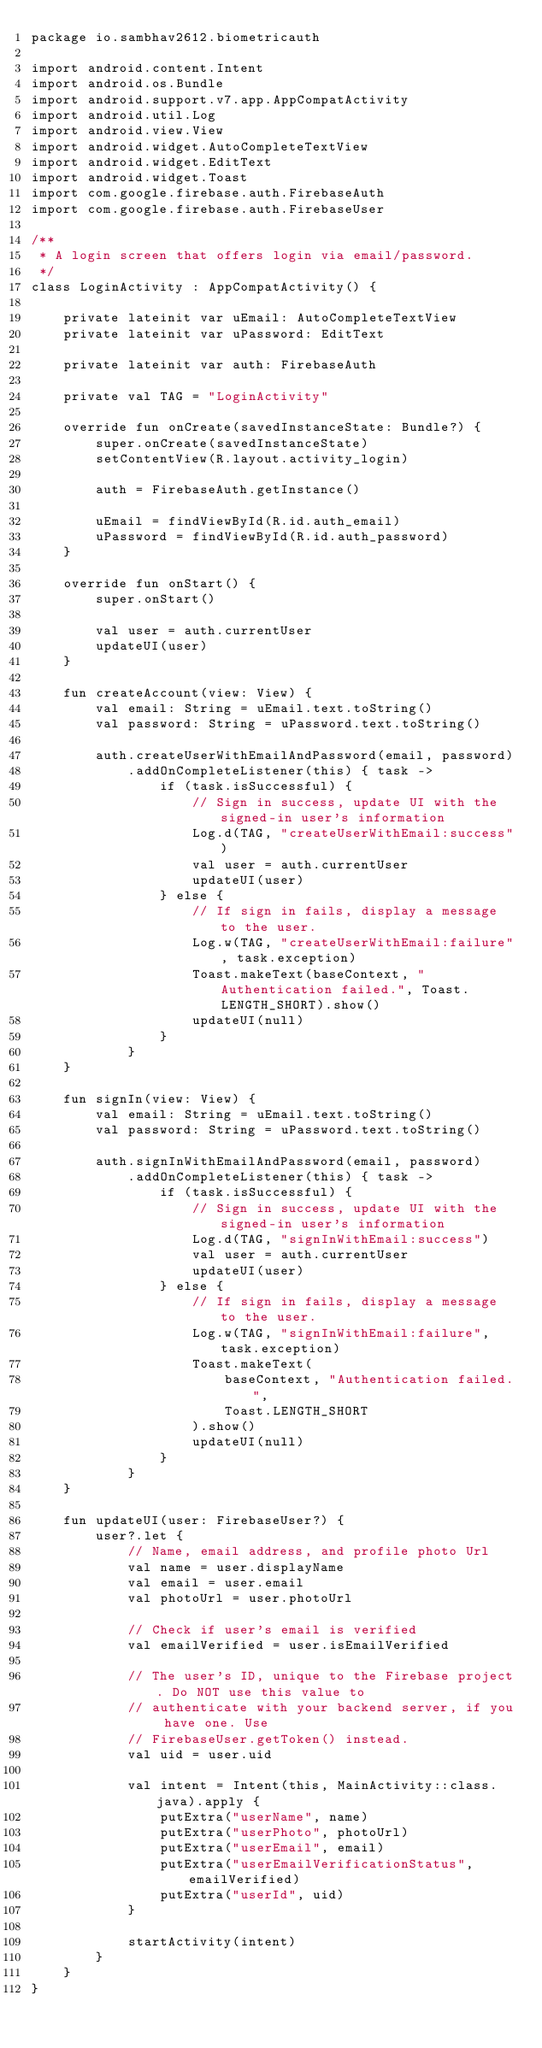<code> <loc_0><loc_0><loc_500><loc_500><_Kotlin_>package io.sambhav2612.biometricauth

import android.content.Intent
import android.os.Bundle
import android.support.v7.app.AppCompatActivity
import android.util.Log
import android.view.View
import android.widget.AutoCompleteTextView
import android.widget.EditText
import android.widget.Toast
import com.google.firebase.auth.FirebaseAuth
import com.google.firebase.auth.FirebaseUser

/**
 * A login screen that offers login via email/password.
 */
class LoginActivity : AppCompatActivity() {

    private lateinit var uEmail: AutoCompleteTextView
    private lateinit var uPassword: EditText

    private lateinit var auth: FirebaseAuth

    private val TAG = "LoginActivity"

    override fun onCreate(savedInstanceState: Bundle?) {
        super.onCreate(savedInstanceState)
        setContentView(R.layout.activity_login)

        auth = FirebaseAuth.getInstance()

        uEmail = findViewById(R.id.auth_email)
        uPassword = findViewById(R.id.auth_password)
    }

    override fun onStart() {
        super.onStart()

        val user = auth.currentUser
        updateUI(user)
    }

    fun createAccount(view: View) {
        val email: String = uEmail.text.toString()
        val password: String = uPassword.text.toString()

        auth.createUserWithEmailAndPassword(email, password)
            .addOnCompleteListener(this) { task ->
                if (task.isSuccessful) {
                    // Sign in success, update UI with the signed-in user's information
                    Log.d(TAG, "createUserWithEmail:success")
                    val user = auth.currentUser
                    updateUI(user)
                } else {
                    // If sign in fails, display a message to the user.
                    Log.w(TAG, "createUserWithEmail:failure", task.exception)
                    Toast.makeText(baseContext, "Authentication failed.", Toast.LENGTH_SHORT).show()
                    updateUI(null)
                }
            }
    }

    fun signIn(view: View) {
        val email: String = uEmail.text.toString()
        val password: String = uPassword.text.toString()

        auth.signInWithEmailAndPassword(email, password)
            .addOnCompleteListener(this) { task ->
                if (task.isSuccessful) {
                    // Sign in success, update UI with the signed-in user's information
                    Log.d(TAG, "signInWithEmail:success")
                    val user = auth.currentUser
                    updateUI(user)
                } else {
                    // If sign in fails, display a message to the user.
                    Log.w(TAG, "signInWithEmail:failure", task.exception)
                    Toast.makeText(
                        baseContext, "Authentication failed.",
                        Toast.LENGTH_SHORT
                    ).show()
                    updateUI(null)
                }
            }
    }

    fun updateUI(user: FirebaseUser?) {
        user?.let {
            // Name, email address, and profile photo Url
            val name = user.displayName
            val email = user.email
            val photoUrl = user.photoUrl

            // Check if user's email is verified
            val emailVerified = user.isEmailVerified

            // The user's ID, unique to the Firebase project. Do NOT use this value to
            // authenticate with your backend server, if you have one. Use
            // FirebaseUser.getToken() instead.
            val uid = user.uid

            val intent = Intent(this, MainActivity::class.java).apply {
                putExtra("userName", name)
                putExtra("userPhoto", photoUrl)
                putExtra("userEmail", email)
                putExtra("userEmailVerificationStatus", emailVerified)
                putExtra("userId", uid)
            }

            startActivity(intent)
        }
    }
}
</code> 